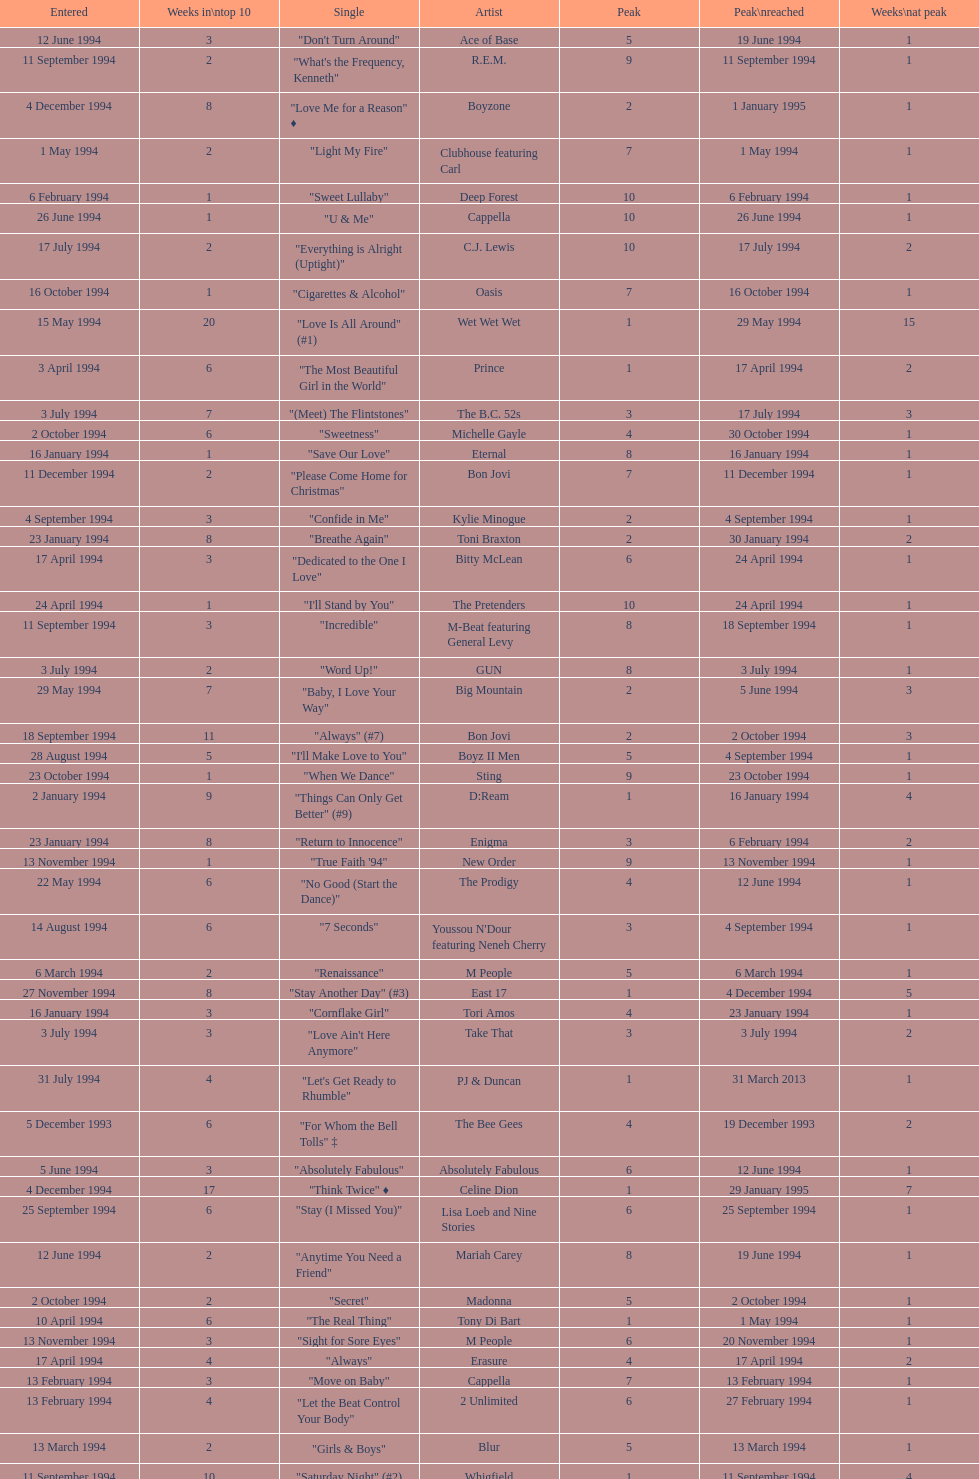Which artist only has its single entered on 2 january 1994? D:Ream. 